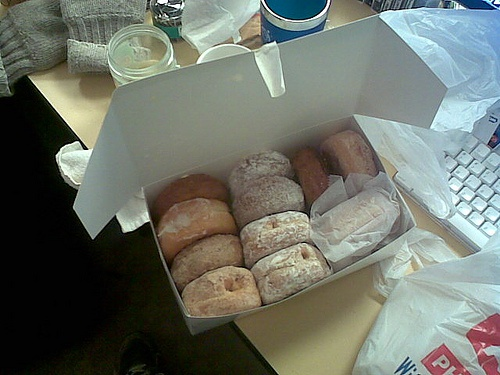Describe the objects in this image and their specific colors. I can see keyboard in gray, lightblue, and darkgray tones, cup in gray, darkgray, and beige tones, donut in gray and tan tones, donut in gray and darkgray tones, and donut in gray, brown, and maroon tones in this image. 